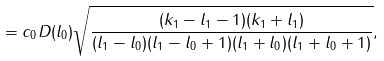Convert formula to latex. <formula><loc_0><loc_0><loc_500><loc_500>= c _ { 0 } D ( l _ { 0 } ) \sqrt { \frac { ( k _ { 1 } - l _ { 1 } - 1 ) ( k _ { 1 } + l _ { 1 } ) } { ( l _ { 1 } - l _ { 0 } ) ( l _ { 1 } - l _ { 0 } + 1 ) ( l _ { 1 } + l _ { 0 } ) ( l _ { 1 } + l _ { 0 } + 1 ) } } ,</formula> 